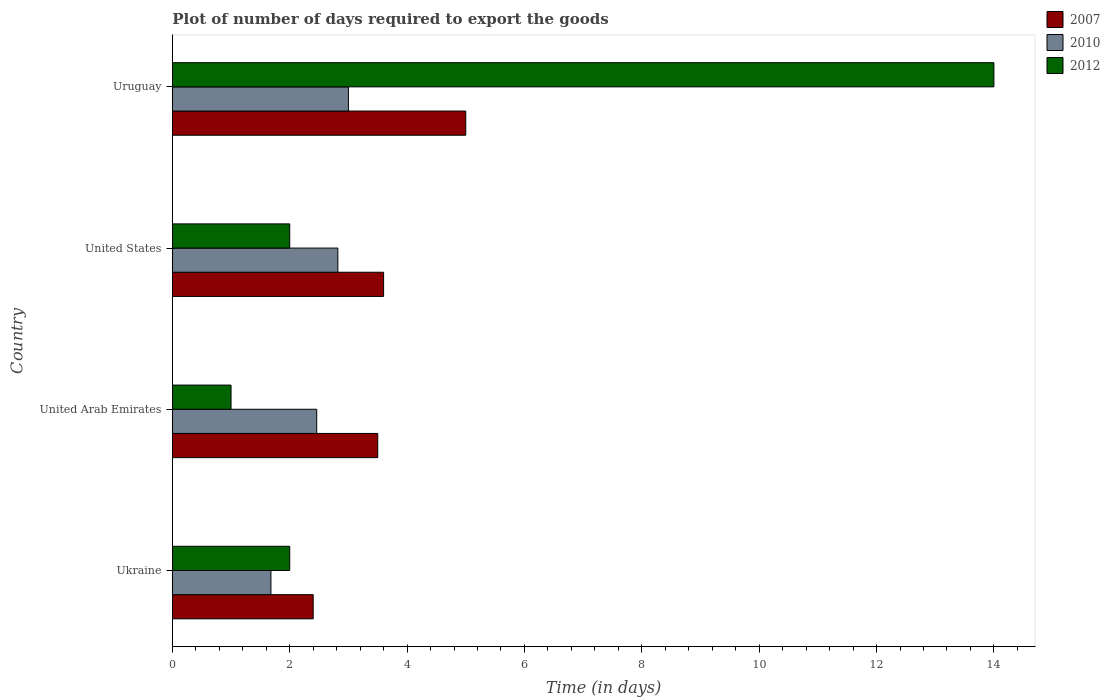Are the number of bars per tick equal to the number of legend labels?
Offer a very short reply. Yes. Are the number of bars on each tick of the Y-axis equal?
Provide a short and direct response. Yes. How many bars are there on the 3rd tick from the top?
Give a very brief answer. 3. What is the label of the 1st group of bars from the top?
Your answer should be very brief. Uruguay. What is the time required to export goods in 2012 in Ukraine?
Your response must be concise. 2. Across all countries, what is the minimum time required to export goods in 2010?
Your response must be concise. 1.68. In which country was the time required to export goods in 2007 maximum?
Your answer should be compact. Uruguay. In which country was the time required to export goods in 2012 minimum?
Offer a terse response. United Arab Emirates. What is the total time required to export goods in 2010 in the graph?
Make the answer very short. 9.96. What is the difference between the time required to export goods in 2007 in Ukraine and that in United States?
Provide a short and direct response. -1.2. What is the difference between the time required to export goods in 2007 in United States and the time required to export goods in 2010 in Uruguay?
Your response must be concise. 0.6. What is the average time required to export goods in 2012 per country?
Give a very brief answer. 4.75. What is the difference between the time required to export goods in 2010 and time required to export goods in 2012 in Uruguay?
Your response must be concise. -11. In how many countries, is the time required to export goods in 2012 greater than 14 days?
Offer a very short reply. 0. What is the ratio of the time required to export goods in 2007 in Ukraine to that in Uruguay?
Provide a short and direct response. 0.48. Is the difference between the time required to export goods in 2010 in United States and Uruguay greater than the difference between the time required to export goods in 2012 in United States and Uruguay?
Your answer should be compact. Yes. What is the difference between the highest and the second highest time required to export goods in 2010?
Your answer should be very brief. 0.18. What does the 1st bar from the bottom in Uruguay represents?
Provide a succinct answer. 2007. How many countries are there in the graph?
Keep it short and to the point. 4. What is the difference between two consecutive major ticks on the X-axis?
Your answer should be compact. 2. Are the values on the major ticks of X-axis written in scientific E-notation?
Offer a very short reply. No. Does the graph contain any zero values?
Offer a terse response. No. Does the graph contain grids?
Provide a succinct answer. No. Where does the legend appear in the graph?
Provide a succinct answer. Top right. How many legend labels are there?
Keep it short and to the point. 3. What is the title of the graph?
Your answer should be very brief. Plot of number of days required to export the goods. What is the label or title of the X-axis?
Keep it short and to the point. Time (in days). What is the label or title of the Y-axis?
Your answer should be compact. Country. What is the Time (in days) in 2010 in Ukraine?
Provide a short and direct response. 1.68. What is the Time (in days) of 2010 in United Arab Emirates?
Make the answer very short. 2.46. What is the Time (in days) in 2012 in United Arab Emirates?
Provide a short and direct response. 1. What is the Time (in days) in 2007 in United States?
Your answer should be compact. 3.6. What is the Time (in days) in 2010 in United States?
Ensure brevity in your answer.  2.82. What is the Time (in days) of 2010 in Uruguay?
Provide a short and direct response. 3. Across all countries, what is the maximum Time (in days) of 2010?
Your answer should be very brief. 3. Across all countries, what is the minimum Time (in days) of 2007?
Offer a terse response. 2.4. Across all countries, what is the minimum Time (in days) of 2010?
Ensure brevity in your answer.  1.68. Across all countries, what is the minimum Time (in days) of 2012?
Keep it short and to the point. 1. What is the total Time (in days) of 2007 in the graph?
Your answer should be compact. 14.5. What is the total Time (in days) of 2010 in the graph?
Offer a very short reply. 9.96. What is the total Time (in days) of 2012 in the graph?
Provide a succinct answer. 19. What is the difference between the Time (in days) of 2010 in Ukraine and that in United Arab Emirates?
Offer a terse response. -0.78. What is the difference between the Time (in days) of 2010 in Ukraine and that in United States?
Make the answer very short. -1.14. What is the difference between the Time (in days) in 2007 in Ukraine and that in Uruguay?
Give a very brief answer. -2.6. What is the difference between the Time (in days) of 2010 in Ukraine and that in Uruguay?
Your answer should be compact. -1.32. What is the difference between the Time (in days) of 2007 in United Arab Emirates and that in United States?
Your answer should be very brief. -0.1. What is the difference between the Time (in days) of 2010 in United Arab Emirates and that in United States?
Offer a very short reply. -0.36. What is the difference between the Time (in days) of 2012 in United Arab Emirates and that in United States?
Make the answer very short. -1. What is the difference between the Time (in days) in 2010 in United Arab Emirates and that in Uruguay?
Keep it short and to the point. -0.54. What is the difference between the Time (in days) in 2012 in United Arab Emirates and that in Uruguay?
Make the answer very short. -13. What is the difference between the Time (in days) in 2010 in United States and that in Uruguay?
Offer a very short reply. -0.18. What is the difference between the Time (in days) of 2012 in United States and that in Uruguay?
Your response must be concise. -12. What is the difference between the Time (in days) in 2007 in Ukraine and the Time (in days) in 2010 in United Arab Emirates?
Make the answer very short. -0.06. What is the difference between the Time (in days) in 2010 in Ukraine and the Time (in days) in 2012 in United Arab Emirates?
Give a very brief answer. 0.68. What is the difference between the Time (in days) of 2007 in Ukraine and the Time (in days) of 2010 in United States?
Your response must be concise. -0.42. What is the difference between the Time (in days) in 2010 in Ukraine and the Time (in days) in 2012 in United States?
Offer a very short reply. -0.32. What is the difference between the Time (in days) of 2007 in Ukraine and the Time (in days) of 2010 in Uruguay?
Your answer should be very brief. -0.6. What is the difference between the Time (in days) of 2007 in Ukraine and the Time (in days) of 2012 in Uruguay?
Ensure brevity in your answer.  -11.6. What is the difference between the Time (in days) in 2010 in Ukraine and the Time (in days) in 2012 in Uruguay?
Your answer should be very brief. -12.32. What is the difference between the Time (in days) of 2007 in United Arab Emirates and the Time (in days) of 2010 in United States?
Offer a very short reply. 0.68. What is the difference between the Time (in days) in 2010 in United Arab Emirates and the Time (in days) in 2012 in United States?
Offer a very short reply. 0.46. What is the difference between the Time (in days) in 2010 in United Arab Emirates and the Time (in days) in 2012 in Uruguay?
Give a very brief answer. -11.54. What is the difference between the Time (in days) of 2007 in United States and the Time (in days) of 2010 in Uruguay?
Make the answer very short. 0.6. What is the difference between the Time (in days) in 2007 in United States and the Time (in days) in 2012 in Uruguay?
Give a very brief answer. -10.4. What is the difference between the Time (in days) of 2010 in United States and the Time (in days) of 2012 in Uruguay?
Offer a terse response. -11.18. What is the average Time (in days) of 2007 per country?
Provide a succinct answer. 3.62. What is the average Time (in days) of 2010 per country?
Provide a short and direct response. 2.49. What is the average Time (in days) of 2012 per country?
Your response must be concise. 4.75. What is the difference between the Time (in days) of 2007 and Time (in days) of 2010 in Ukraine?
Offer a terse response. 0.72. What is the difference between the Time (in days) in 2010 and Time (in days) in 2012 in Ukraine?
Ensure brevity in your answer.  -0.32. What is the difference between the Time (in days) in 2010 and Time (in days) in 2012 in United Arab Emirates?
Ensure brevity in your answer.  1.46. What is the difference between the Time (in days) of 2007 and Time (in days) of 2010 in United States?
Give a very brief answer. 0.78. What is the difference between the Time (in days) in 2010 and Time (in days) in 2012 in United States?
Your answer should be very brief. 0.82. What is the difference between the Time (in days) in 2007 and Time (in days) in 2012 in Uruguay?
Your answer should be compact. -9. What is the difference between the Time (in days) in 2010 and Time (in days) in 2012 in Uruguay?
Your answer should be compact. -11. What is the ratio of the Time (in days) of 2007 in Ukraine to that in United Arab Emirates?
Your answer should be compact. 0.69. What is the ratio of the Time (in days) in 2010 in Ukraine to that in United Arab Emirates?
Your answer should be very brief. 0.68. What is the ratio of the Time (in days) of 2012 in Ukraine to that in United Arab Emirates?
Offer a terse response. 2. What is the ratio of the Time (in days) of 2007 in Ukraine to that in United States?
Make the answer very short. 0.67. What is the ratio of the Time (in days) of 2010 in Ukraine to that in United States?
Give a very brief answer. 0.6. What is the ratio of the Time (in days) of 2007 in Ukraine to that in Uruguay?
Your response must be concise. 0.48. What is the ratio of the Time (in days) in 2010 in Ukraine to that in Uruguay?
Make the answer very short. 0.56. What is the ratio of the Time (in days) in 2012 in Ukraine to that in Uruguay?
Give a very brief answer. 0.14. What is the ratio of the Time (in days) of 2007 in United Arab Emirates to that in United States?
Provide a succinct answer. 0.97. What is the ratio of the Time (in days) in 2010 in United Arab Emirates to that in United States?
Your answer should be very brief. 0.87. What is the ratio of the Time (in days) in 2010 in United Arab Emirates to that in Uruguay?
Offer a terse response. 0.82. What is the ratio of the Time (in days) in 2012 in United Arab Emirates to that in Uruguay?
Your answer should be very brief. 0.07. What is the ratio of the Time (in days) in 2007 in United States to that in Uruguay?
Your answer should be compact. 0.72. What is the ratio of the Time (in days) of 2010 in United States to that in Uruguay?
Provide a succinct answer. 0.94. What is the ratio of the Time (in days) of 2012 in United States to that in Uruguay?
Provide a short and direct response. 0.14. What is the difference between the highest and the second highest Time (in days) in 2007?
Provide a short and direct response. 1.4. What is the difference between the highest and the second highest Time (in days) in 2010?
Your response must be concise. 0.18. What is the difference between the highest and the lowest Time (in days) in 2007?
Offer a very short reply. 2.6. What is the difference between the highest and the lowest Time (in days) of 2010?
Make the answer very short. 1.32. 